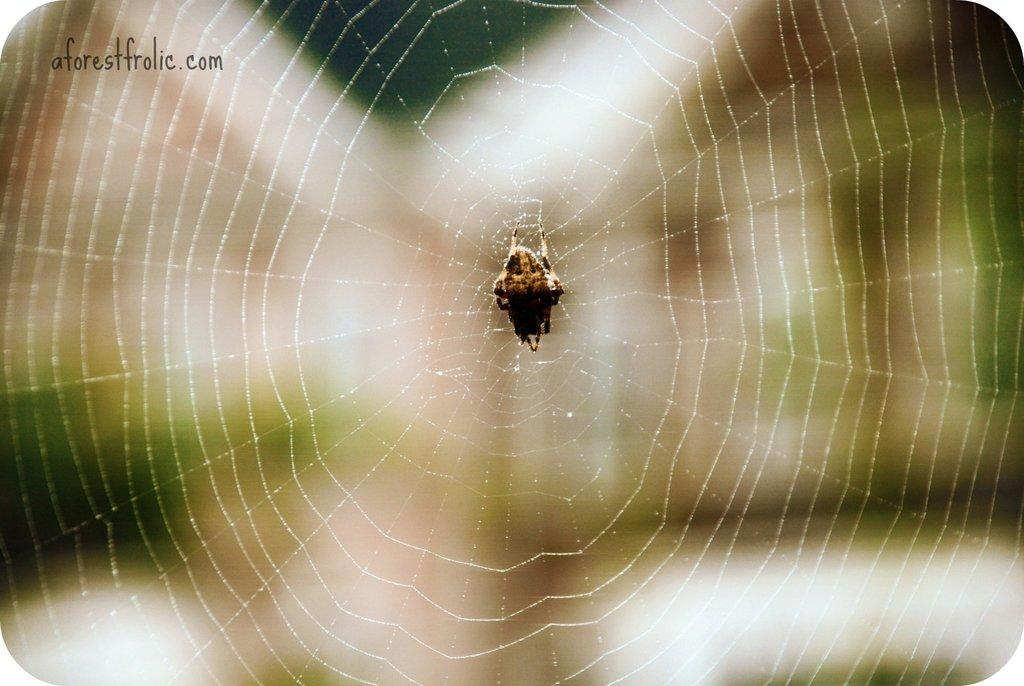What is the main subject of the image? The main subject of the image is a spider. Where is the spider located in the image? The spider is on a web. What type of milk is the spider drinking from the ball in the image? There is no milk, ball, or any activity involving drinking in the image; it only features a spider on a web. 